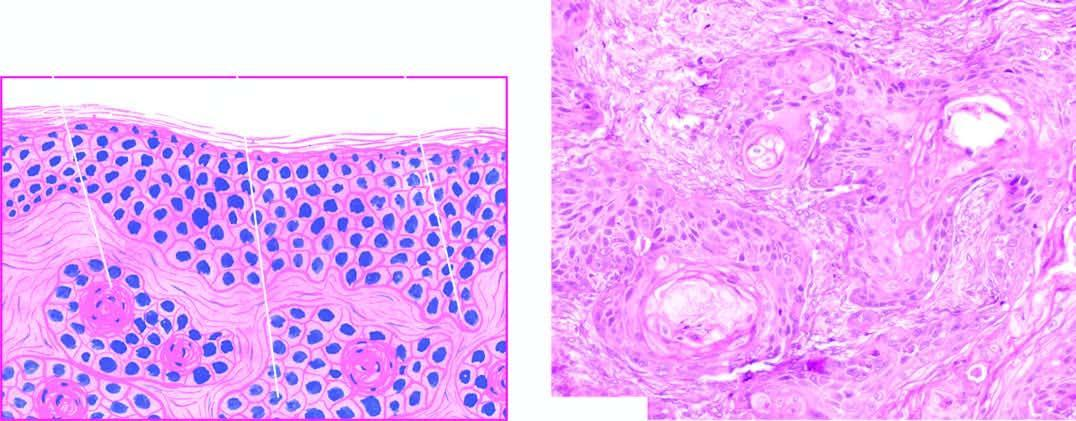s a partly formed unerupted tooth invaded by downward proliferating epidermal masses of cells which show atypical features?
Answer the question using a single word or phrase. No 